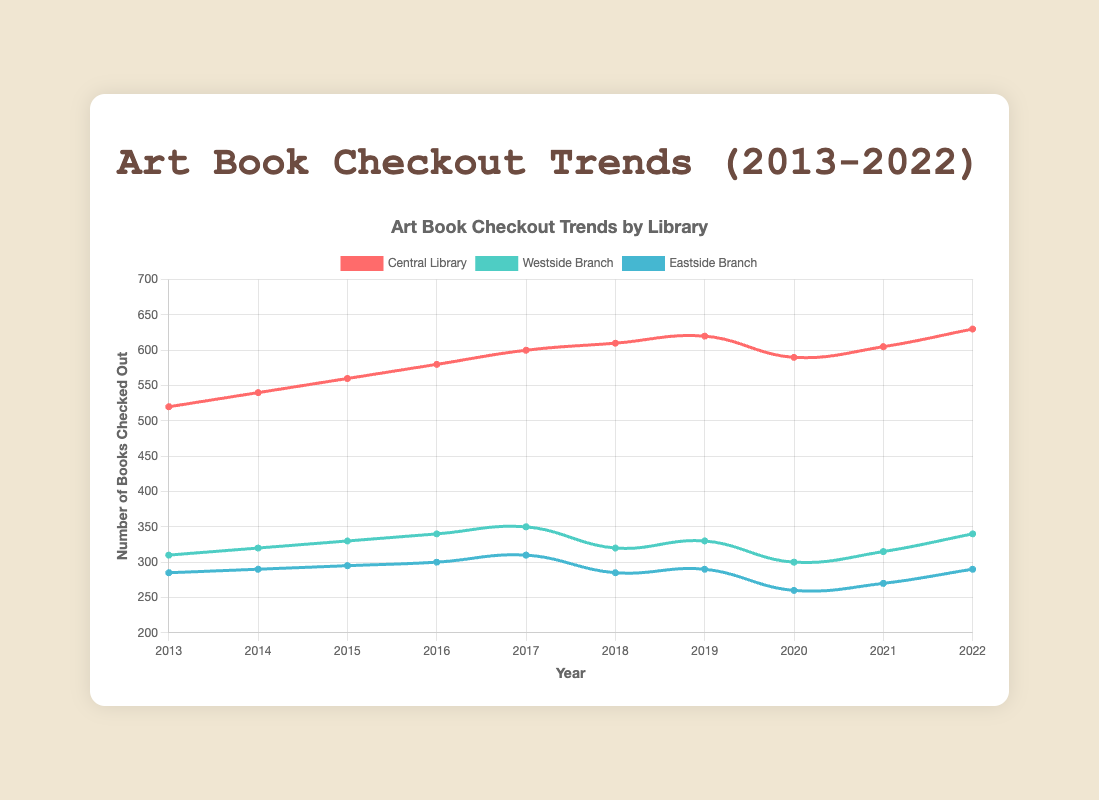Which library had the highest number of art-related books checked out in 2022? The figure shows the number of books checked out by year for three libraries. In 2022, the library with the highest bar (or line point) is the Central Library.
Answer: Central Library What is the overall trend in the number of books checked out from the Central Library from 2013 to 2022? The Central Library shows an increasing trend from 2013 to 2022, with minor fluctuations especially between 2019 and 2021.
Answer: Increasing trend In which year did the Eastside Branch experience a decrease in the number of books checked out compared to the previous year? By observing the line for the Eastside Branch, we can see a decrease from 310 in 2017 to 285 in 2018.
Answer: 2018 How does the number of art books checked out in 2020 from the Westside Branch compare to those in 2016? For the Westside Branch, the figure shows that in 2020, the number is 300, which is lower than 340 in 2016.
Answer: Lower in 2020 Which library had the least consistent trend over the decade? The Westside Branch shows more fluctuations and deviations in the number of books checked out over the decade compared to the other two libraries.
Answer: Westside Branch What was the average number of books checked out from the Central Library over the first five years (2013-2017)? Sum the number of books checked out from 2013 to 2017 for the Central Library: 520 + 540 + 560 + 580 + 600 = 2800. Then divide by 5: 2800 / 5 = 560.
Answer: 560 How did the impact of 2020 (likely due to the pandemic) vary between the three libraries? Comparing the number of books checked out in 2020 to 2019: Central Library decreased from 620 to 590 (-30), Westside Branch decreased from 330 to 300 (-30), and Eastside Branch decreased from 290 to 260 (-30). All had the same decrease of 30 but percentages differ.
Answer: All had a decrease of 30 What is the total number of books checked out in 2016 among all three libraries? Add the number of books checked out in 2016: Central Library (580), Westside Branch (340), and Eastside Branch (300). So, 580 + 340 + 300 = 1220.
Answer: 1220 Between which years did the Central Library see the largest increase in the number of books checked out? The largest increase can be seen from 2018 to 2019, where the number increased from 610 to 620, as all other year increases are same (20) or no change.
Answer: 2018-2019 What color corresponds to the Westside Branch's data representation in the chart? The figure indicates that the Westside Branch is represented by a green line.
Answer: Green 